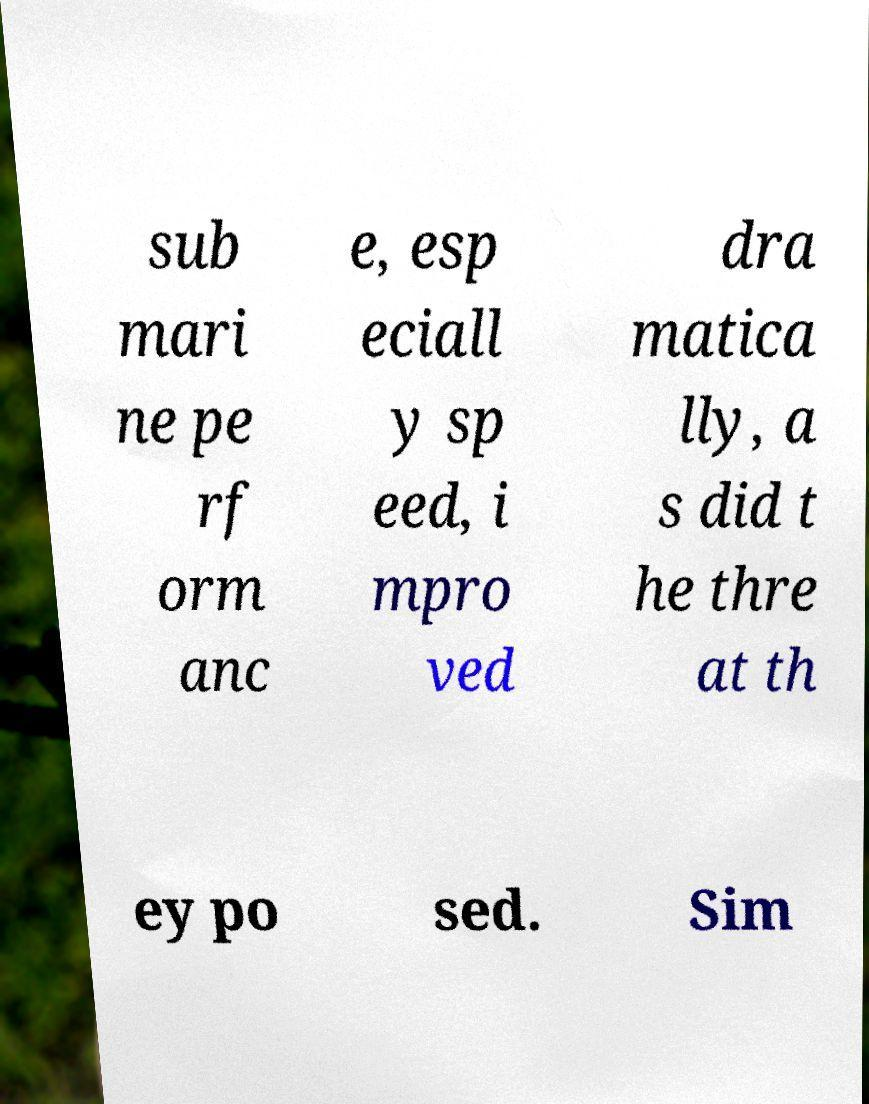Could you extract and type out the text from this image? sub mari ne pe rf orm anc e, esp eciall y sp eed, i mpro ved dra matica lly, a s did t he thre at th ey po sed. Sim 